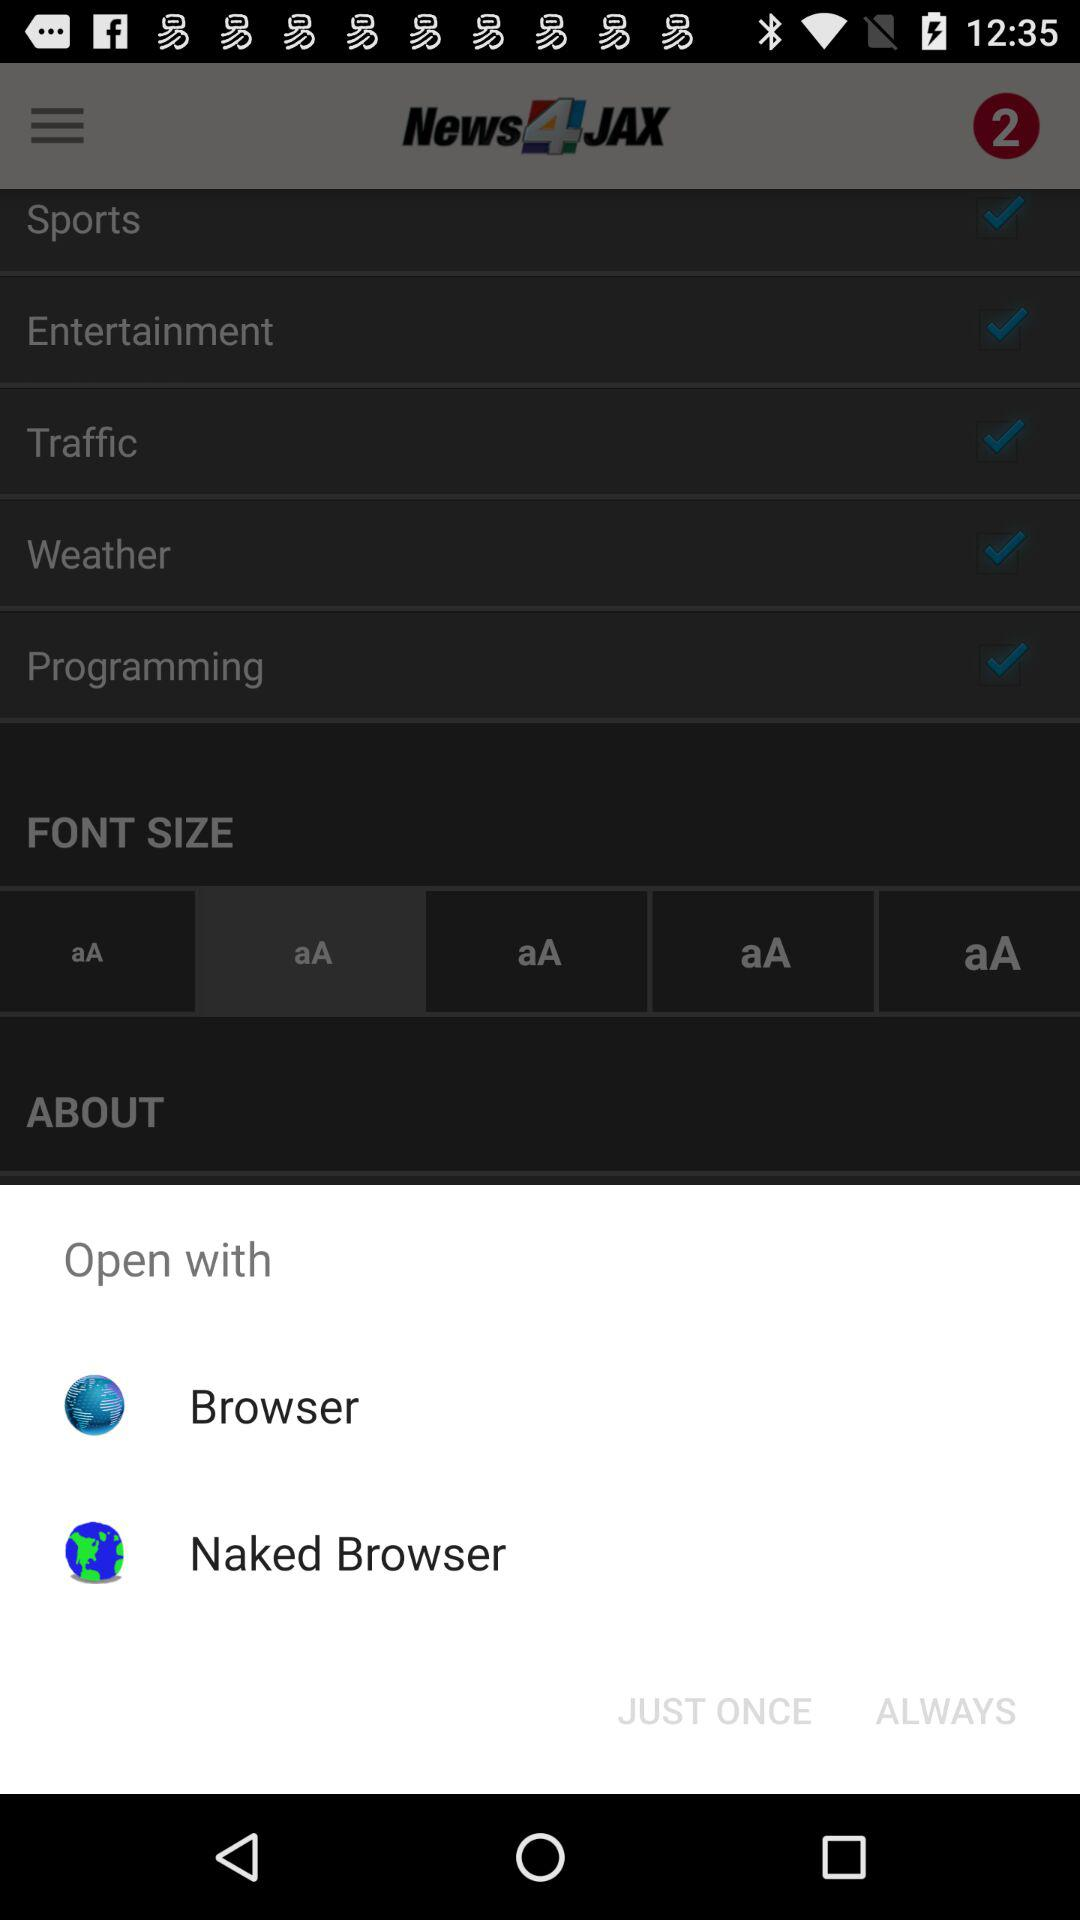What application can be used to open the content? The application that can be used is "Naked Browser". 